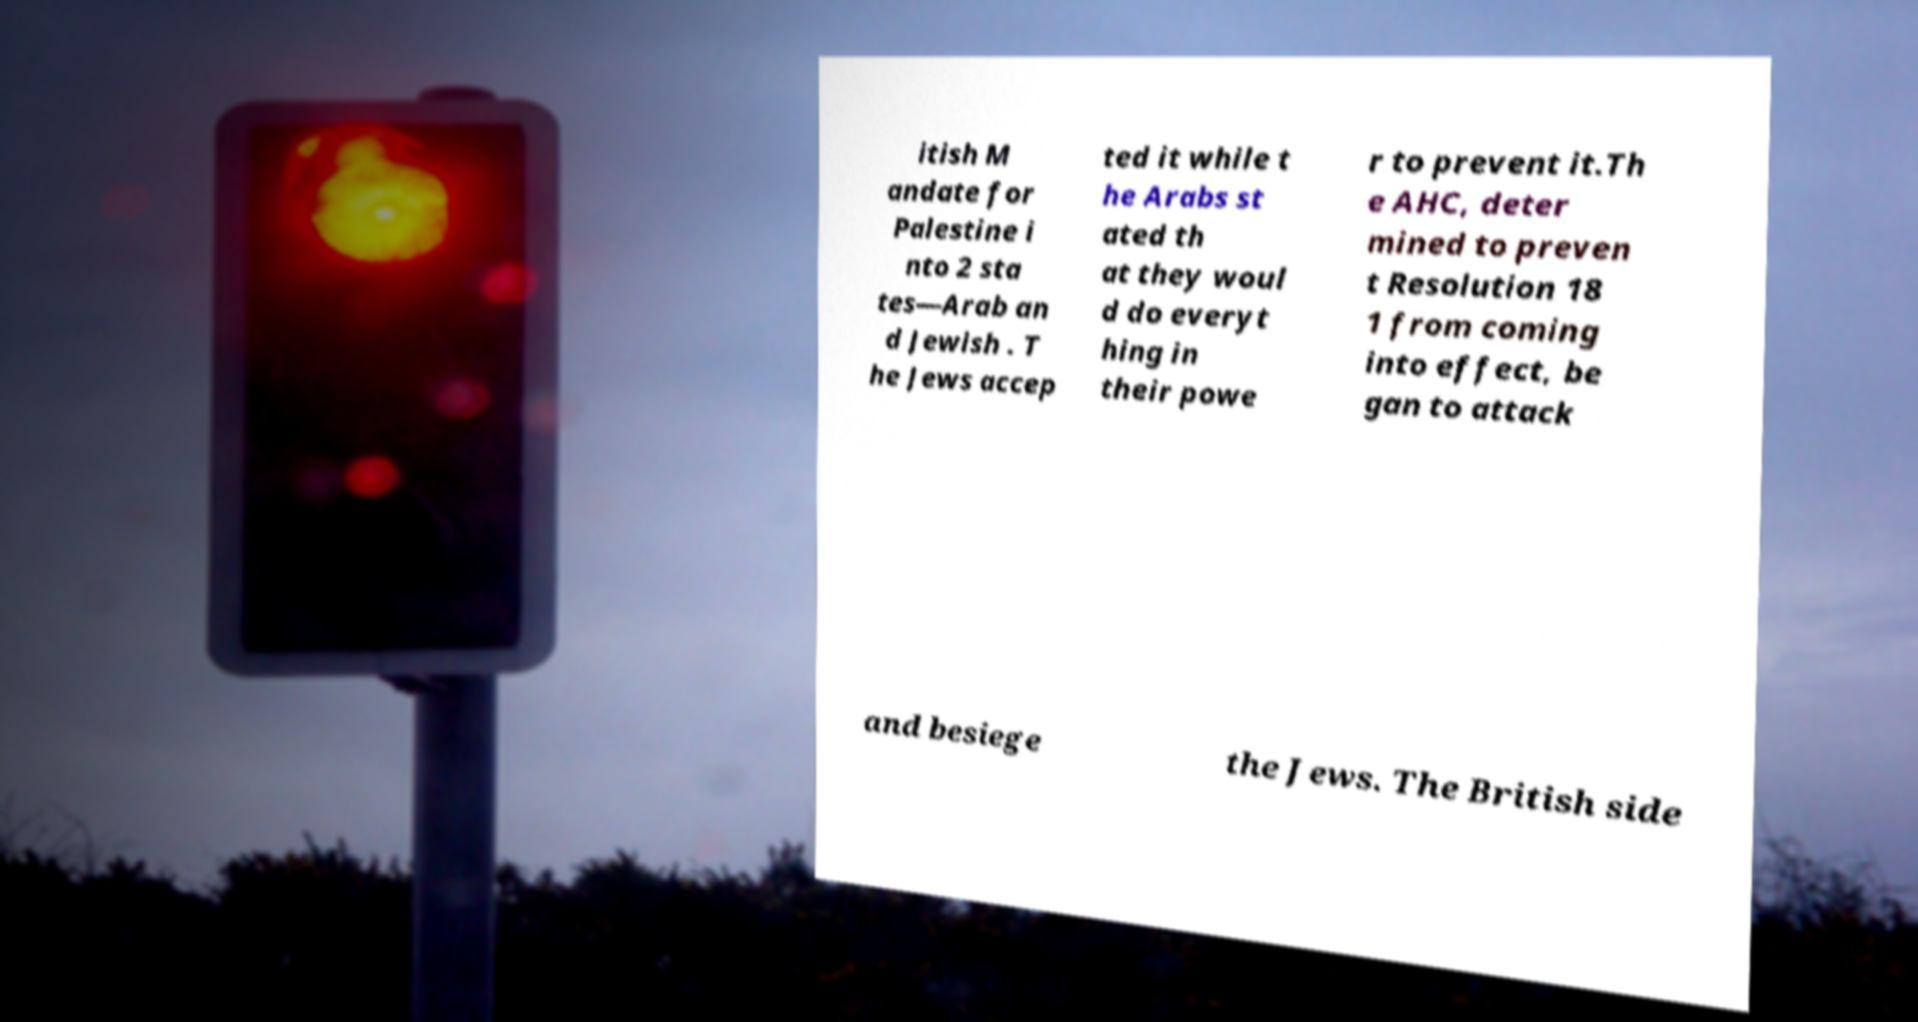Can you accurately transcribe the text from the provided image for me? itish M andate for Palestine i nto 2 sta tes—Arab an d Jewish . T he Jews accep ted it while t he Arabs st ated th at they woul d do everyt hing in their powe r to prevent it.Th e AHC, deter mined to preven t Resolution 18 1 from coming into effect, be gan to attack and besiege the Jews. The British side 